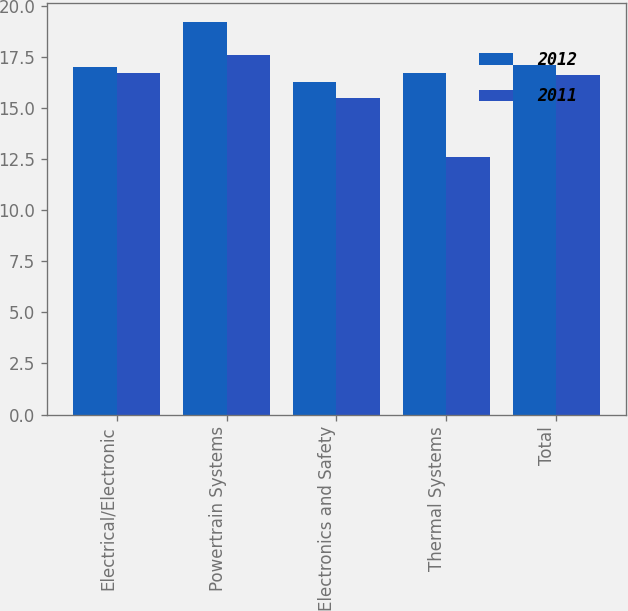Convert chart. <chart><loc_0><loc_0><loc_500><loc_500><stacked_bar_chart><ecel><fcel>Electrical/Electronic<fcel>Powertrain Systems<fcel>Electronics and Safety<fcel>Thermal Systems<fcel>Total<nl><fcel>2012<fcel>17<fcel>19.2<fcel>16.3<fcel>16.7<fcel>17.1<nl><fcel>2011<fcel>16.7<fcel>17.6<fcel>15.5<fcel>12.6<fcel>16.6<nl></chart> 